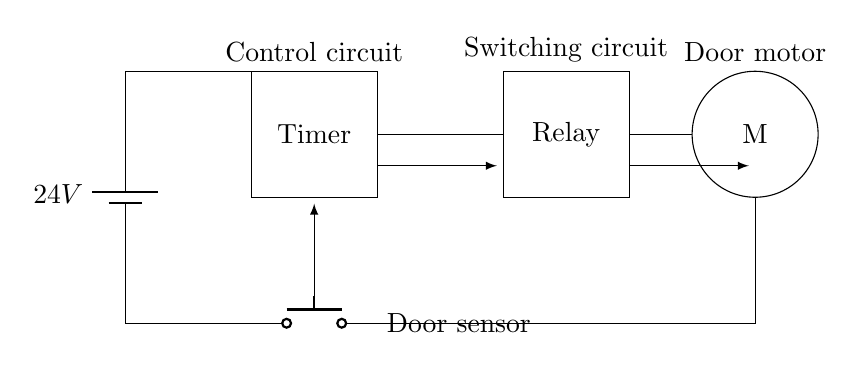What is the voltage of this circuit? The circuit is powered by a battery, which provides a voltage of 24 volts as indicated on the battery symbol.
Answer: 24 volts What is the function of the timer in this circuit? The timer controls the operation of the relay, allowing for timed activation of the door motor based on input from the door sensor.
Answer: Timing control What type of motor is represented in the diagram? The diagram uses a circle labeled "M," which signifies a motor; it does not specify the type, but it is typically an electric motor used for door operation.
Answer: Electric motor How many main components does the circuit have? The circuit consists of four key components: a power supply, a timer, a relay, and a motor; these are essential for its operation.
Answer: Four components What initiates the operation of the motor? The operation of the motor is initiated when the door sensor is activated, which sends a signal to the timer, leading to relay activation.
Answer: Door sensor Which component acts as a switching device in the circuit? The relay serves as the switching device, allowing the motor to be turned on or off based on the signal from the timer.
Answer: Relay What is the role of the door sensor in this circuit? The role of the door sensor is to detect the presence or absence of a door, serving as the input trigger for the timer to start its function.
Answer: Input trigger 